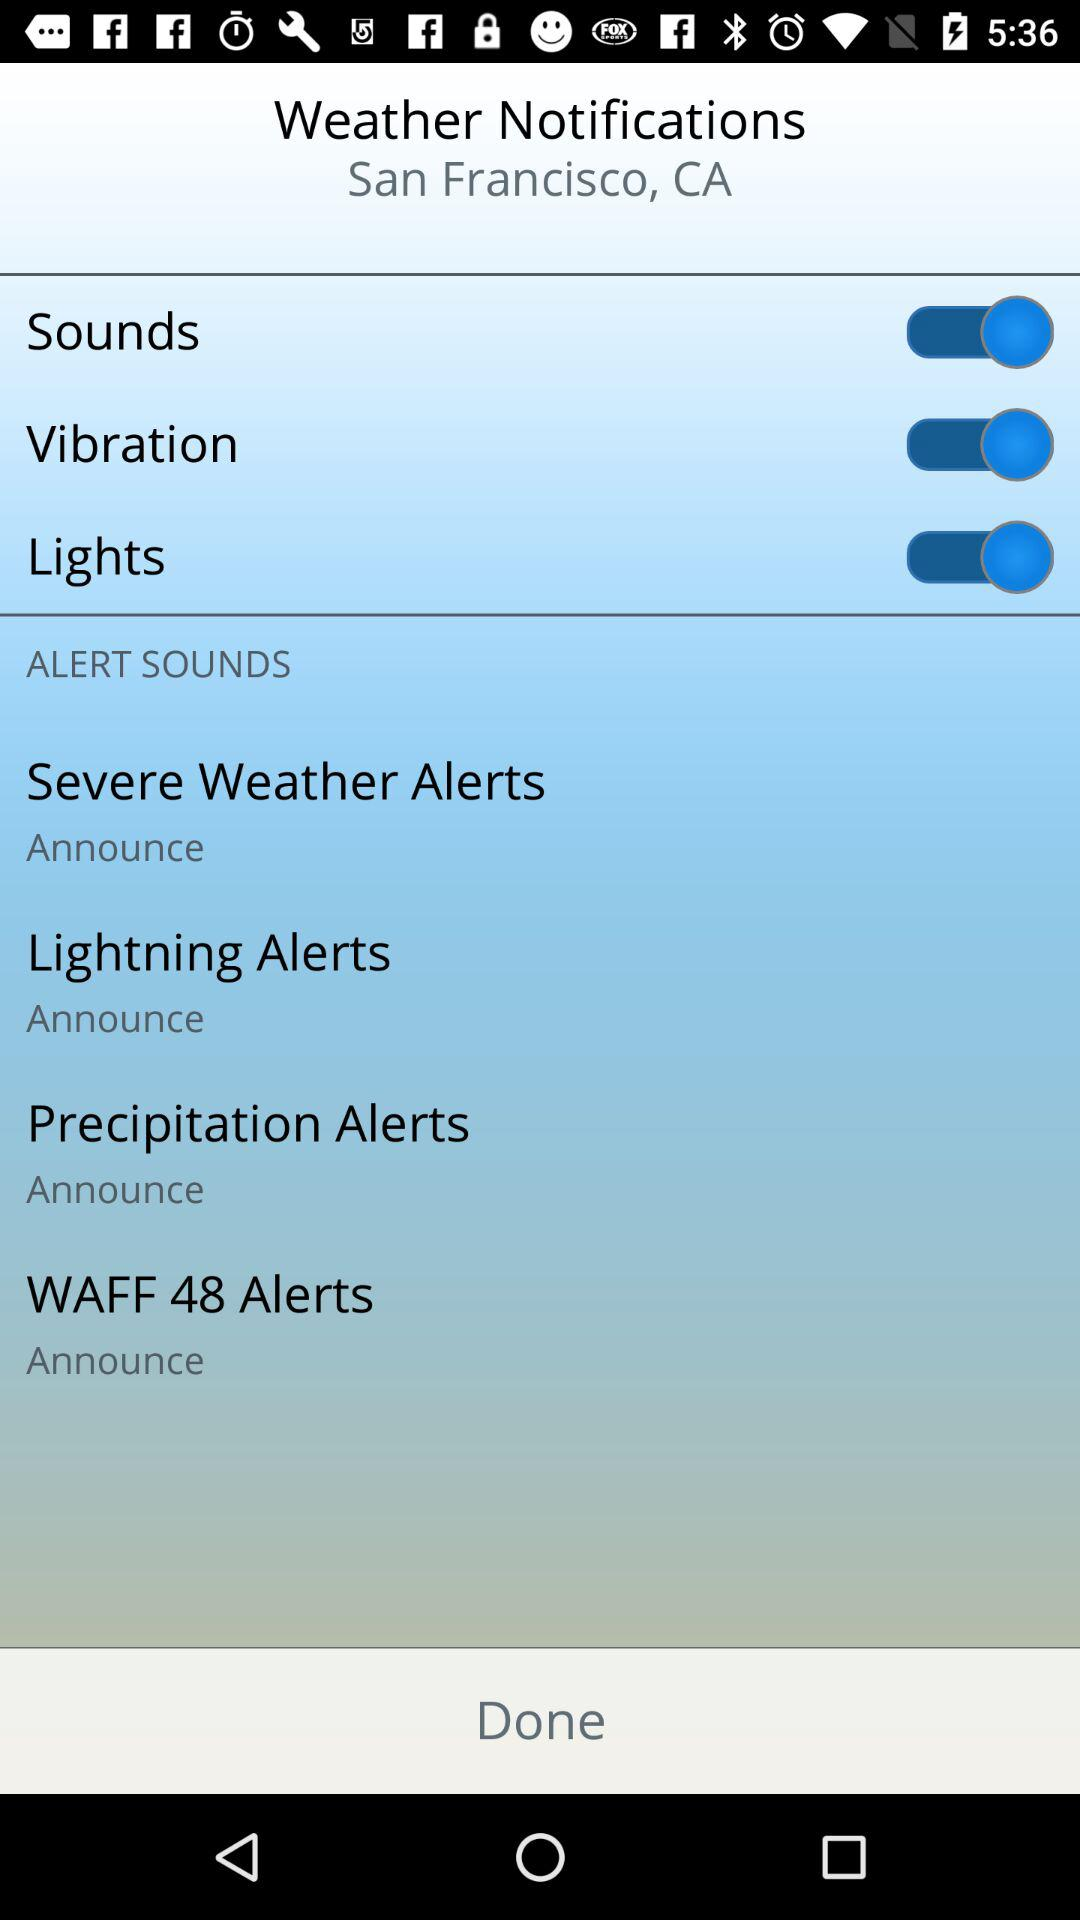How many alert sounds are there that have an announce option?
Answer the question using a single word or phrase. 4 